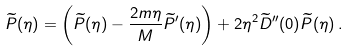Convert formula to latex. <formula><loc_0><loc_0><loc_500><loc_500>\widetilde { P } ( \eta ) = \left ( \widetilde { P } ( \eta ) - \frac { 2 m \eta } { M } \widetilde { P } ^ { \prime } ( \eta ) \right ) + 2 \eta ^ { 2 } \widetilde { D } ^ { \prime \prime } ( 0 ) \widetilde { P } ( \eta ) \, .</formula> 